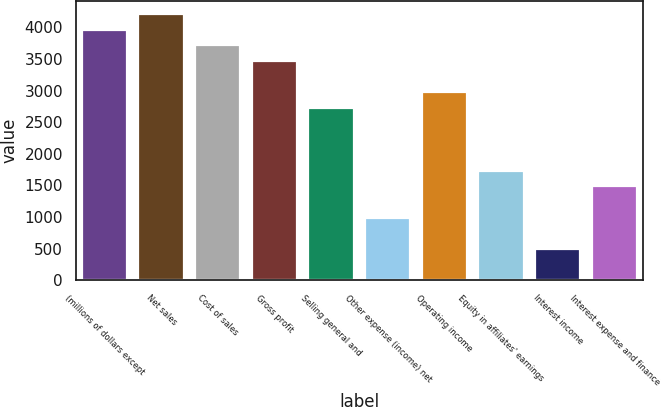<chart> <loc_0><loc_0><loc_500><loc_500><bar_chart><fcel>(millions of dollars except<fcel>Net sales<fcel>Cost of sales<fcel>Gross profit<fcel>Selling general and<fcel>Other expense (income) net<fcel>Operating income<fcel>Equity in affiliates' earnings<fcel>Interest income<fcel>Interest expense and finance<nl><fcel>3964.98<fcel>4212.73<fcel>3717.23<fcel>3469.48<fcel>2726.23<fcel>991.98<fcel>2973.98<fcel>1735.23<fcel>496.48<fcel>1487.48<nl></chart> 